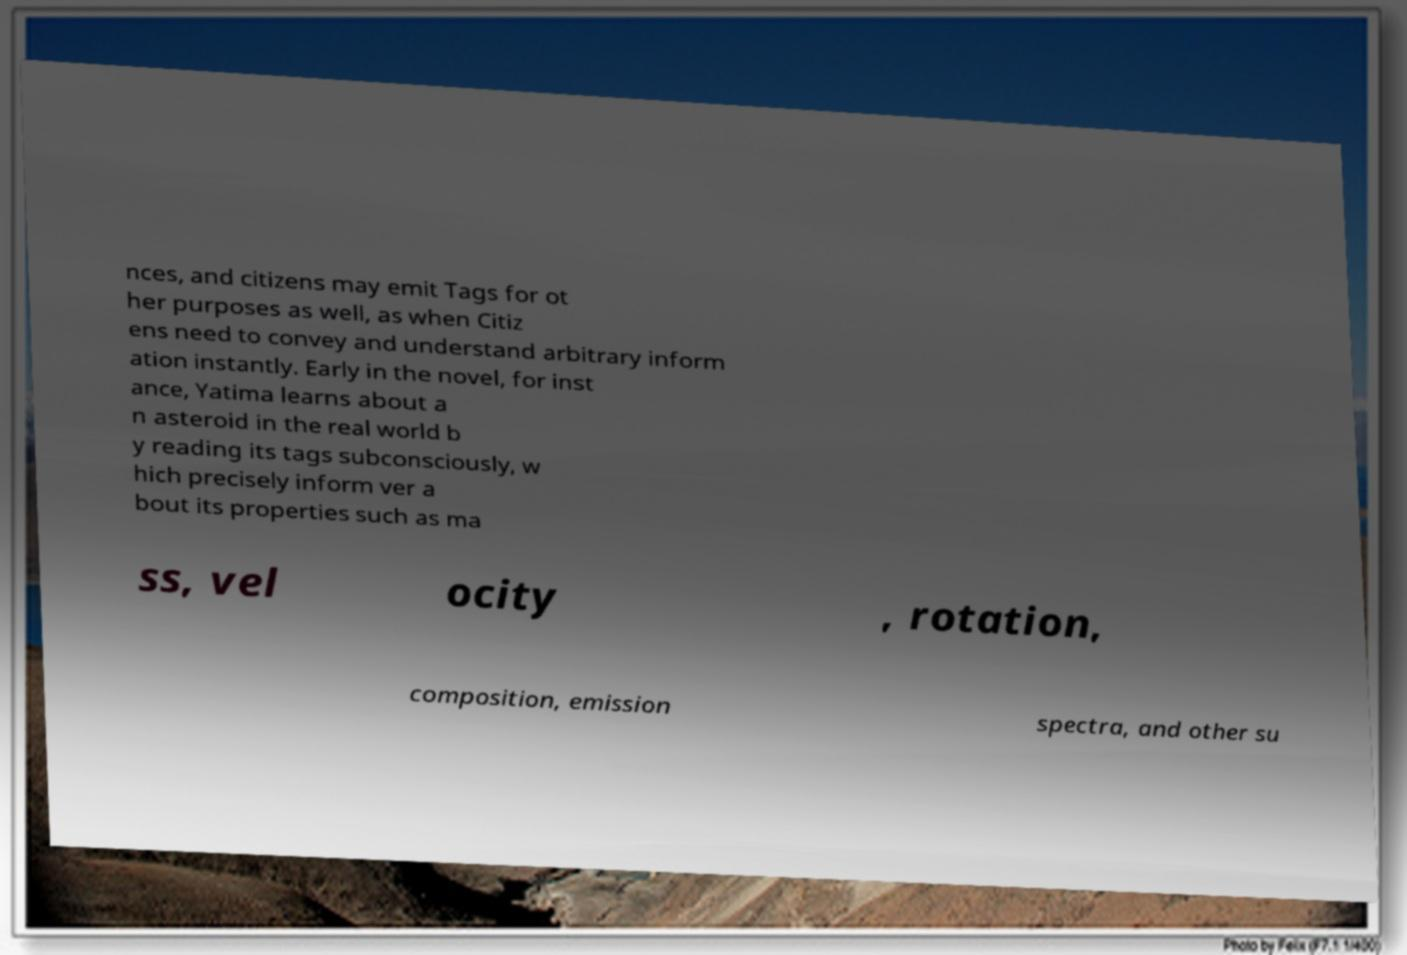Can you accurately transcribe the text from the provided image for me? nces, and citizens may emit Tags for ot her purposes as well, as when Citiz ens need to convey and understand arbitrary inform ation instantly. Early in the novel, for inst ance, Yatima learns about a n asteroid in the real world b y reading its tags subconsciously, w hich precisely inform ver a bout its properties such as ma ss, vel ocity , rotation, composition, emission spectra, and other su 